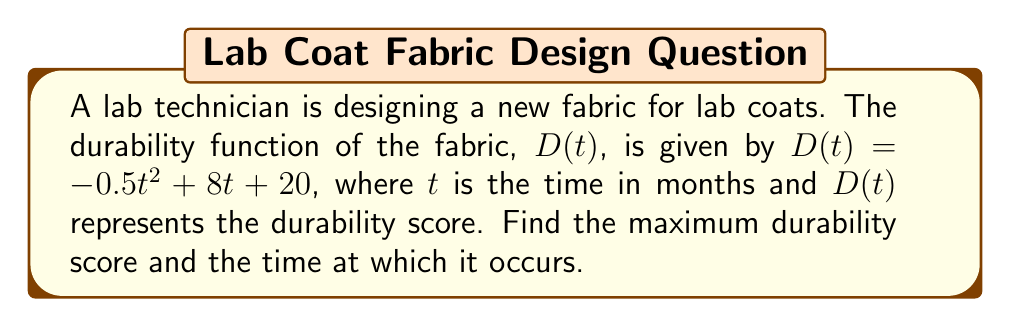Show me your answer to this math problem. To find the maximum durability score and the time at which it occurs, we need to follow these steps:

1) The maximum point of the durability function will occur where its derivative is zero. So, let's first find the derivative of $D(t)$.

   $D(t) = -0.5t^2 + 8t + 20$
   $D'(t) = -t + 8$

2) Now, we set the derivative equal to zero and solve for $t$:

   $D'(t) = 0$
   $-t + 8 = 0$
   $-t = -8$
   $t = 8$

3) This critical point $t = 8$ could be a maximum, minimum, or neither. To confirm it's a maximum, we can check the second derivative:

   $D''(t) = -1$

   Since $D''(t)$ is negative for all $t$, the critical point is indeed a maximum.

4) To find the maximum durability score, we plug $t = 8$ back into the original function:

   $D(8) = -0.5(8)^2 + 8(8) + 20$
   $= -0.5(64) + 64 + 20$
   $= -32 + 64 + 20$
   $= 52$

Therefore, the maximum durability score is 52, occurring at 8 months.
Answer: Maximum durability score: 52; Time: 8 months 